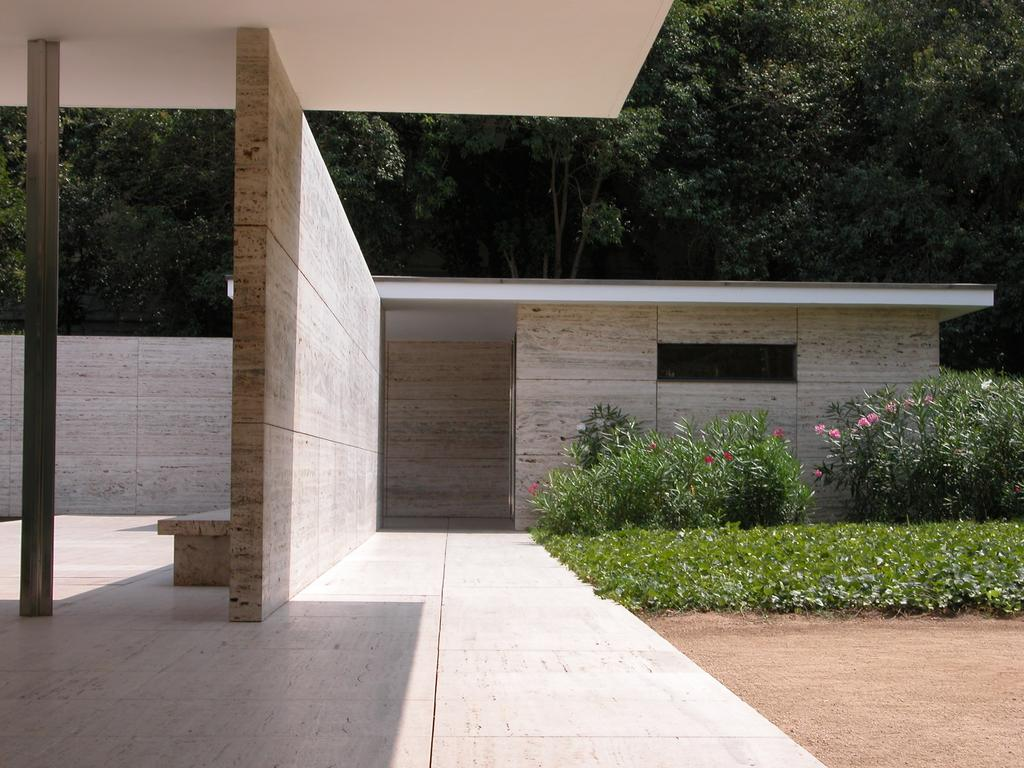What type of surface is visible at the bottom of the image? There is a floor in the image. What type of structure is visible on the sides of the image? There is a wall in the image. What type of vegetation is on the right side of the image? There are many plants on the right side of the image. What type of vegetation is visible in the background of the image? There are many trees in the background of the image. Can you see any visible veins on the plants in the image? There is no mention of veins on the plants in the image, and it is not possible to see veins on plants in a photograph. Is there a fire visible in the image? There is no fire visible in the image. 